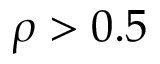Convert formula to latex. <formula><loc_0><loc_0><loc_500><loc_500>\rho > 0 . 5</formula> 